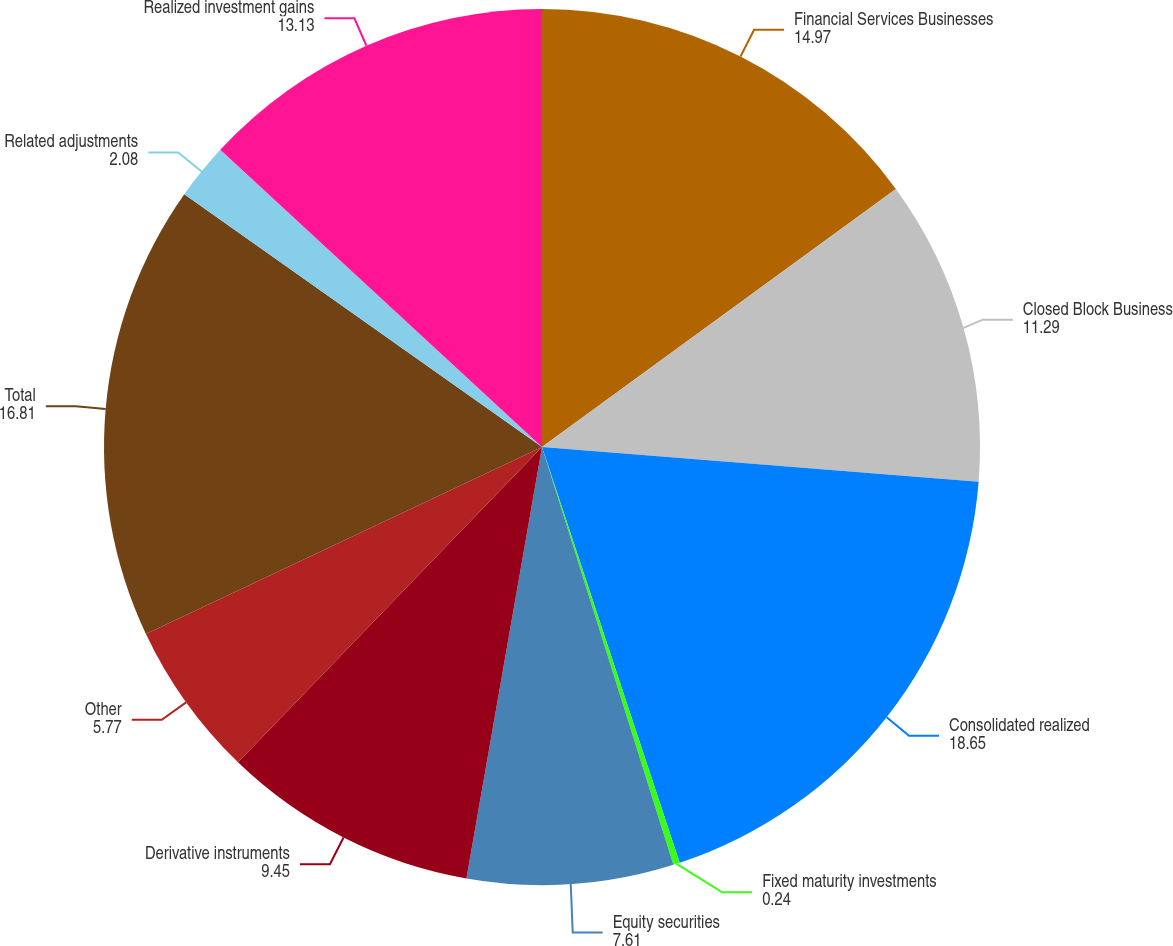Convert chart. <chart><loc_0><loc_0><loc_500><loc_500><pie_chart><fcel>Financial Services Businesses<fcel>Closed Block Business<fcel>Consolidated realized<fcel>Fixed maturity investments<fcel>Equity securities<fcel>Derivative instruments<fcel>Other<fcel>Total<fcel>Related adjustments<fcel>Realized investment gains<nl><fcel>14.97%<fcel>11.29%<fcel>18.65%<fcel>0.24%<fcel>7.61%<fcel>9.45%<fcel>5.77%<fcel>16.81%<fcel>2.08%<fcel>13.13%<nl></chart> 